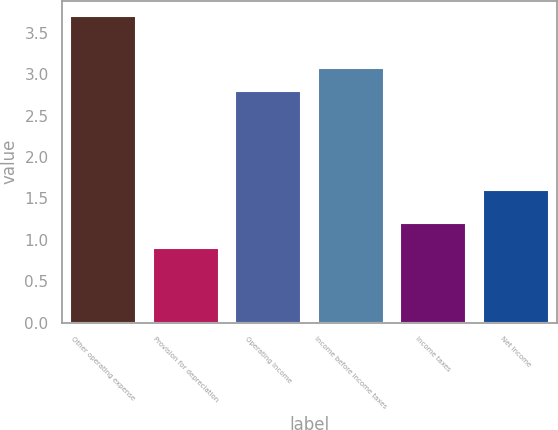Convert chart. <chart><loc_0><loc_0><loc_500><loc_500><bar_chart><fcel>Other operating expense<fcel>Provision for depreciation<fcel>Operating Income<fcel>Income before income taxes<fcel>Income taxes<fcel>Net Income<nl><fcel>3.7<fcel>0.9<fcel>2.8<fcel>3.08<fcel>1.2<fcel>1.6<nl></chart> 